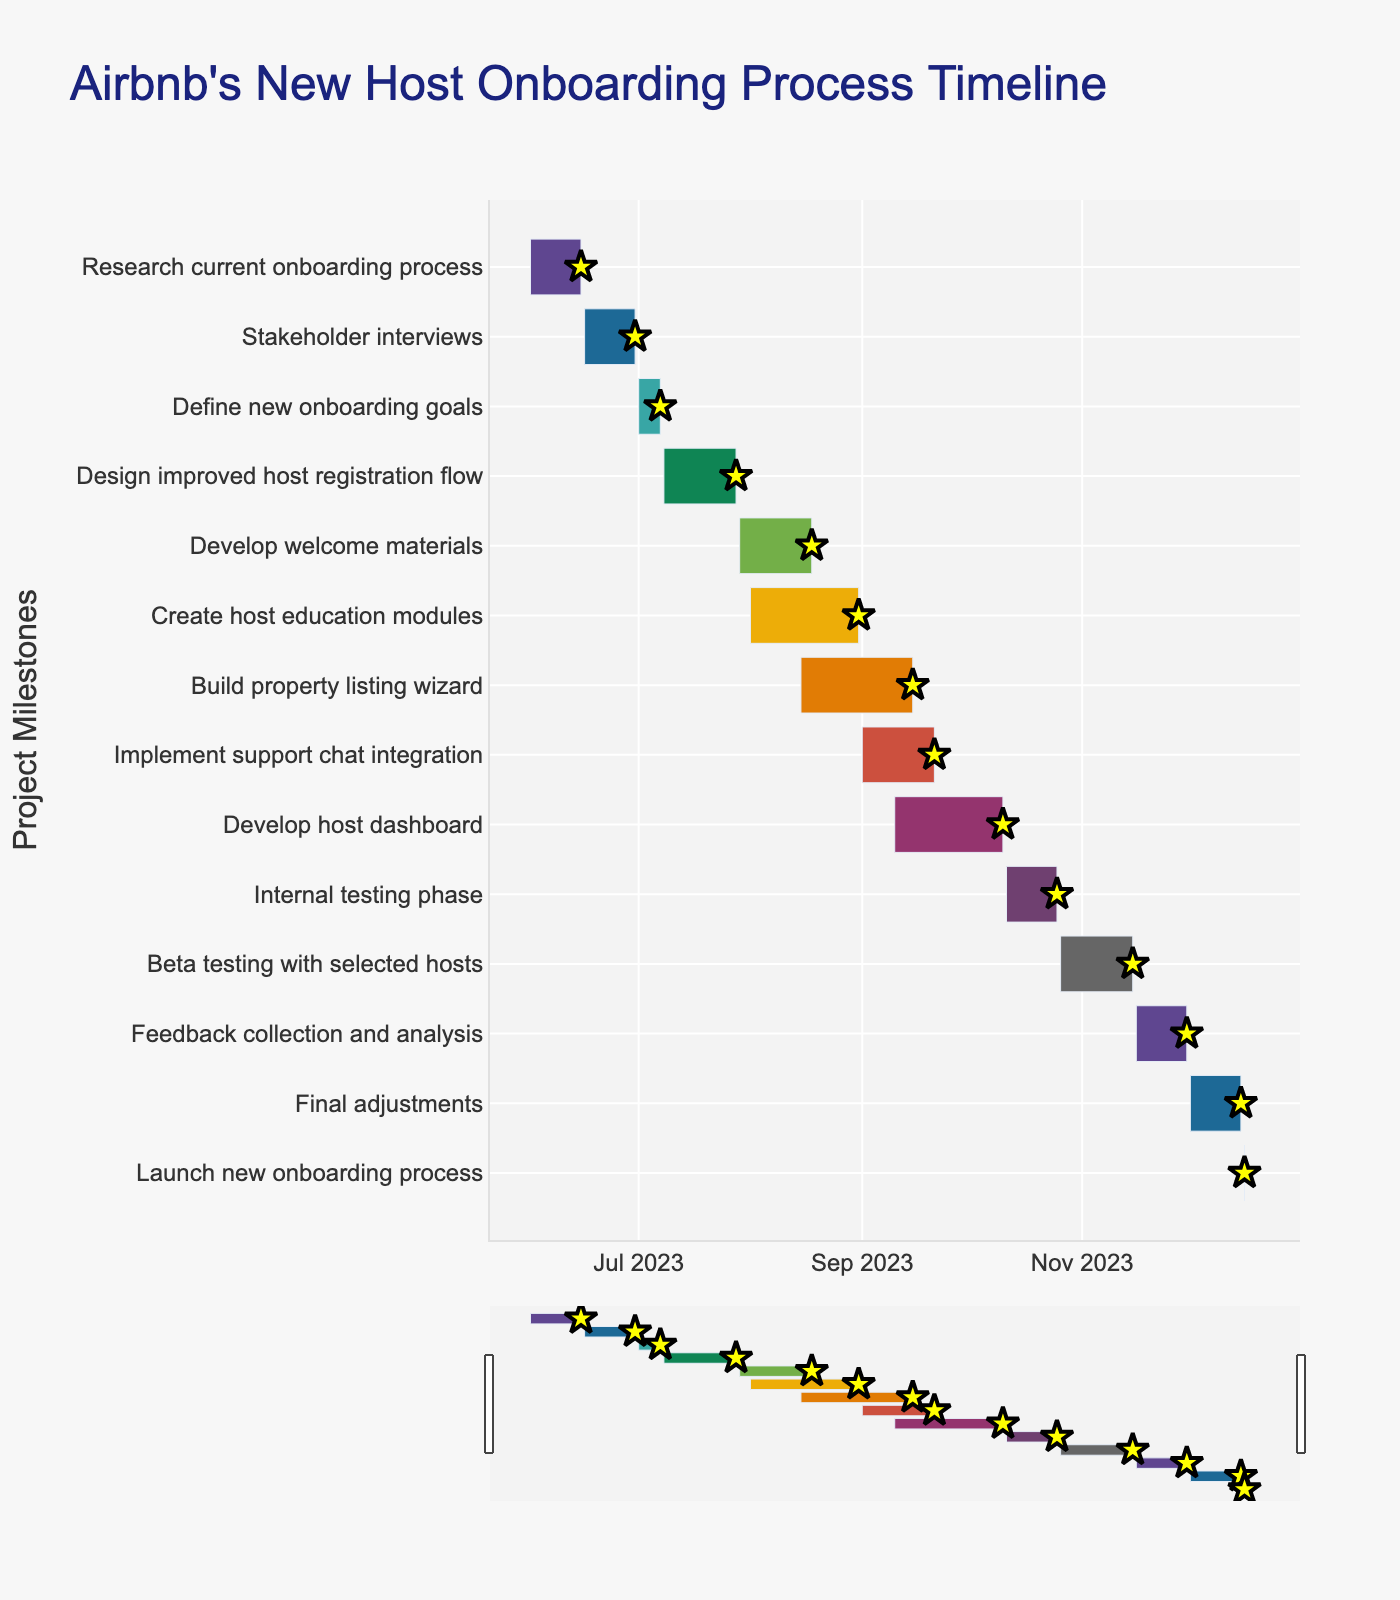What is the title of the Gantt chart? The title of the Gantt chart is usually placed at the top of the figure; in this case, it reads "Airbnb's New Host Onboarding Process Timeline"
Answer: Airbnb's New Host Onboarding Process Timeline What are the dates for the "Stakeholder interviews" task? By looking at the row labeled "Stakeholder interviews," we can see the start and end dates which are June 16, 2023, and June 30, 2023, respectively.
Answer: June 16, 2023 - June 30, 2023 Which task has the shortest duration? To find the shortest duration, observe the bars corresponding to each task and notice that the "Launch new onboarding process" task has the shortest bar and only lasts one day.
Answer: Launch new onboarding process How many tasks start in August 2023? By examining the Gantt chart and focusing on the start dates, you'll count three tasks starting in August: "Develop welcome materials" (August 1), "Create host education modules" (August 1), and "Build property listing wizard" (August 15).
Answer: 3 Which task takes place entirely within the month of December 2023? By checking the start and end dates of tasks within December, you find that "Final adjustments" takes place from December 1 to December 15 only within December.
Answer: Final adjustments Which two tasks overlap in their timeframes the most? By analyzing overlapping bars, "Develop host dashboard" (September 10 to October 10) and "Implement support chat integration" (September 1 to September 21) have overlapping periods totaling 11 days.
Answer: Develop host dashboard and Implement support chat integration When does the "Internal testing phase" begin and end? The "Internal testing phase" starts on October 11, 2023, and ends on October 25, 2023, as shown in the chart.
Answer: October 11, 2023 - October 25, 2023 How long does the "Create host education modules" task last? The duration is determined by counting the days from the start to the end date; in this case, August 1 to August 31, making it 31 days.
Answer: 31 days What is the duration of the entire timeline for the new onboarding process? The timeline starts from the earliest task "Research current onboarding process" on June 1, 2023, to the "Launch new onboarding process" on December 16, 2023, amounting to 199 days.
Answer: 199 days Which task starts immediately after "Design improved host registration flow" ends? "Design improved host registration flow" ends on July 28, 2023, and the next task "Develop welcome materials" starts on July 29, 2023, without any gap.
Answer: Develop welcome materials 